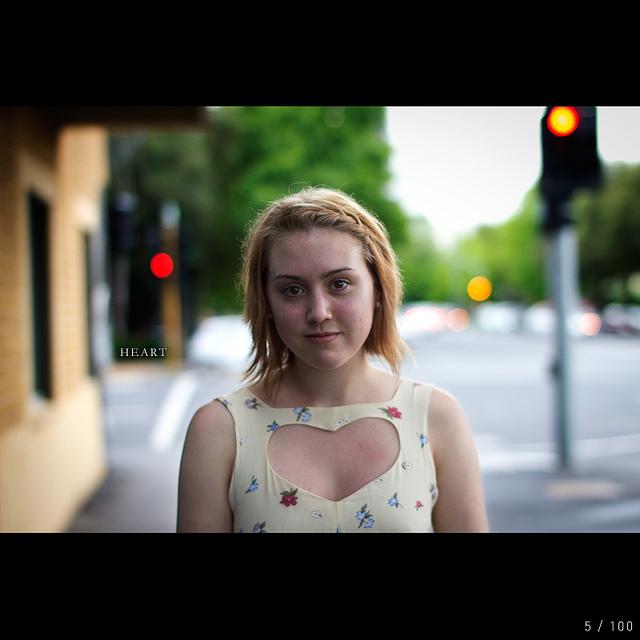How is the front of the girl's hair styled?
Short answer required. Held back. What color is the traffic light?
Concise answer only. Red. Does this woman have sunglasses?
Quick response, please. No. What is unusual about this woman?
Be succinct. Her shirt. What pattern does her dress and skin make?
Be succinct. Heart. What is the girl doing?
Short answer required. Standing. 